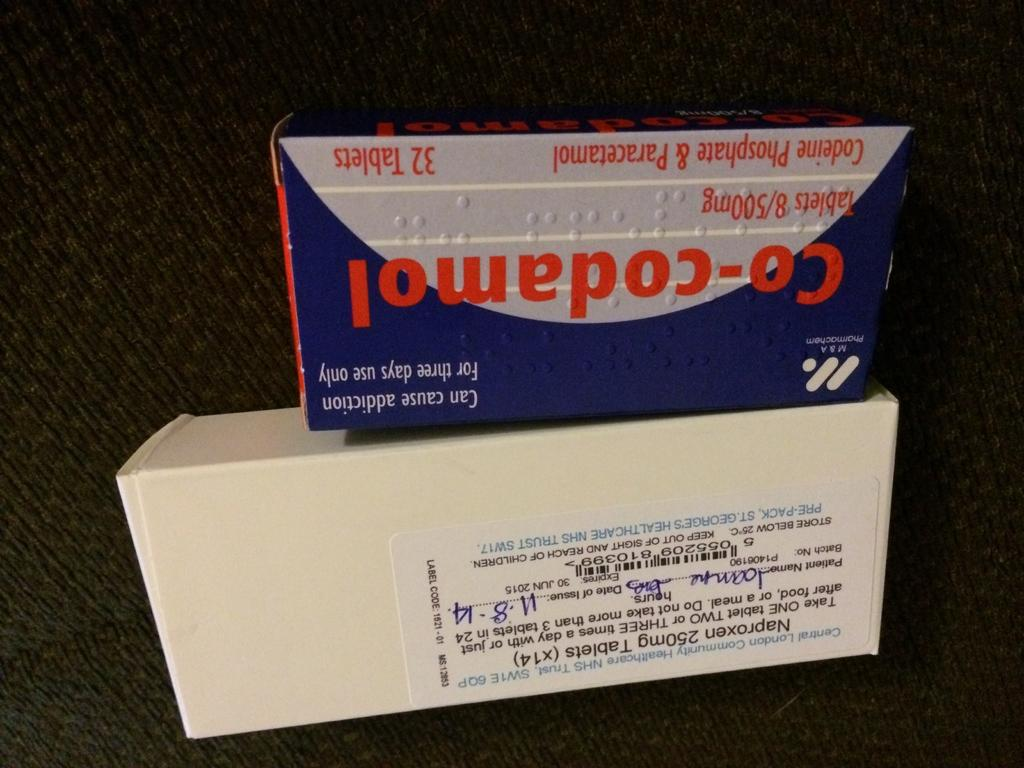<image>
Provide a brief description of the given image. A box of Naproxen 250mg tablets on top of a box of Co-codamol tablets 